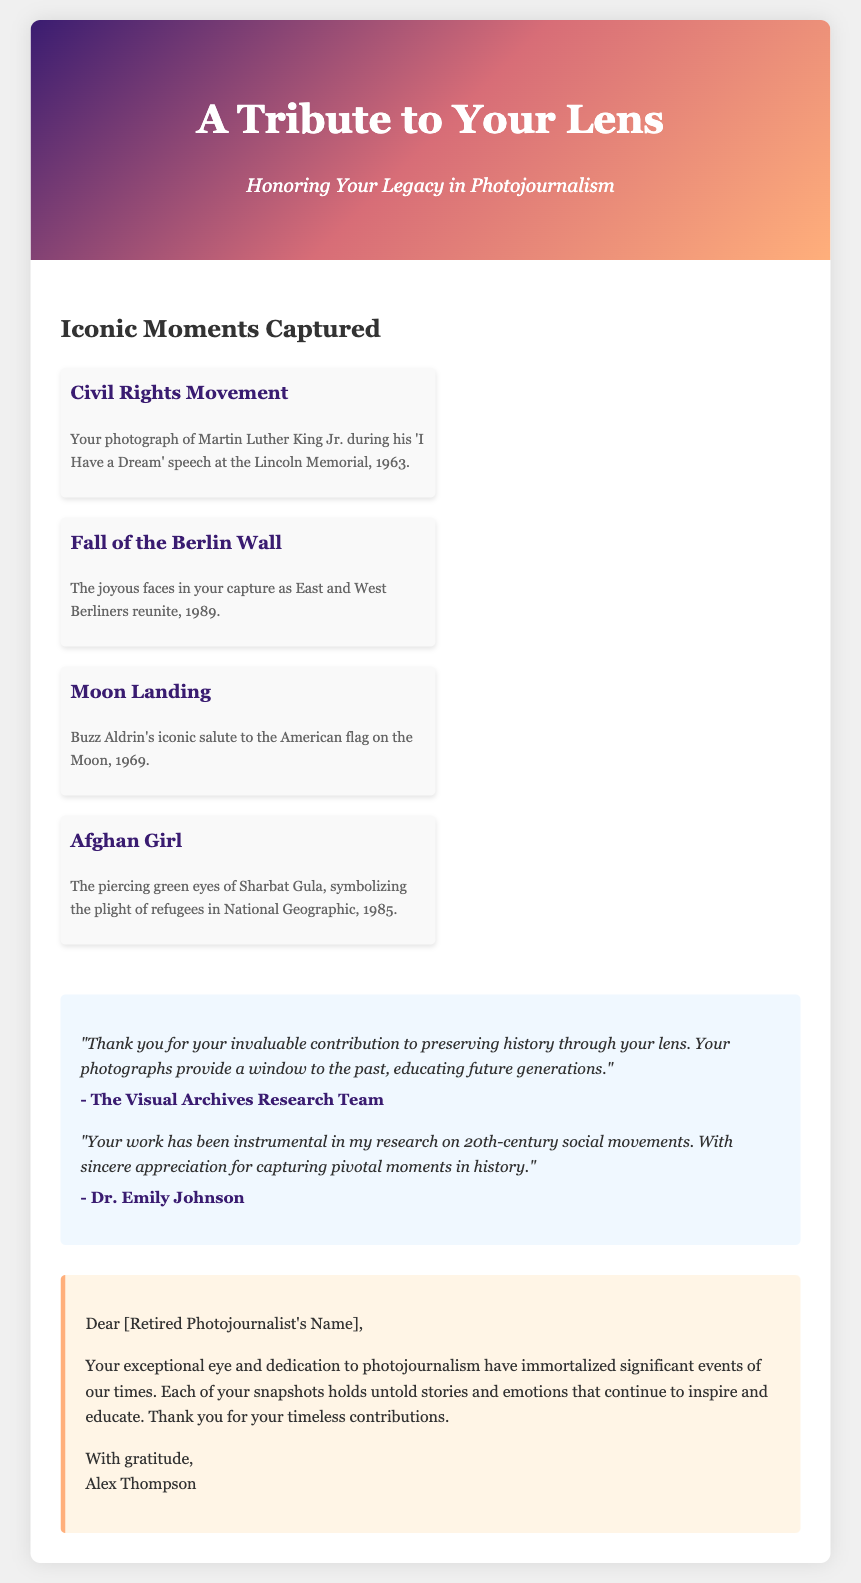What is the title of the greeting card? The title is prominently displayed at the top of the document as part of the front cover design.
Answer: A Tribute to Your Lens In what year was the Moon landing photographed? The document mentions the Moon landing photograph with a specific date included in the description.
Answer: 1969 Who is depicted in the photograph from the Civil Rights Movement? The caption under the corresponding photo clearly identifies the historical figure from that significant event.
Answer: Martin Luther King Jr What is the name of the iconic photograph featuring a young girl? The document titles this famous photograph with a widely recognized name that refers to its subject.
Answer: Afghan Girl How many messages of appreciation are included in the document? The document lists messages under a specific section, each representing gratitude for the photojournalist's work.
Answer: Two What is the gradient color scheme used on the front cover? The front cover section describes a gradient that transitions through multiple colors, creating a visually appealing backdrop.
Answer: #3a1c71, #d76d77, #ffaf7b What is the position of the send-off message in the personal message section? The personal message section includes a typical closing line, indicating the placement of the sender's name.
Answer: Last Who authored one of the gratitude messages in the document? The document includes names associated with the appreciation messages, identifying one contributor.
Answer: Dr. Emily Johnson 